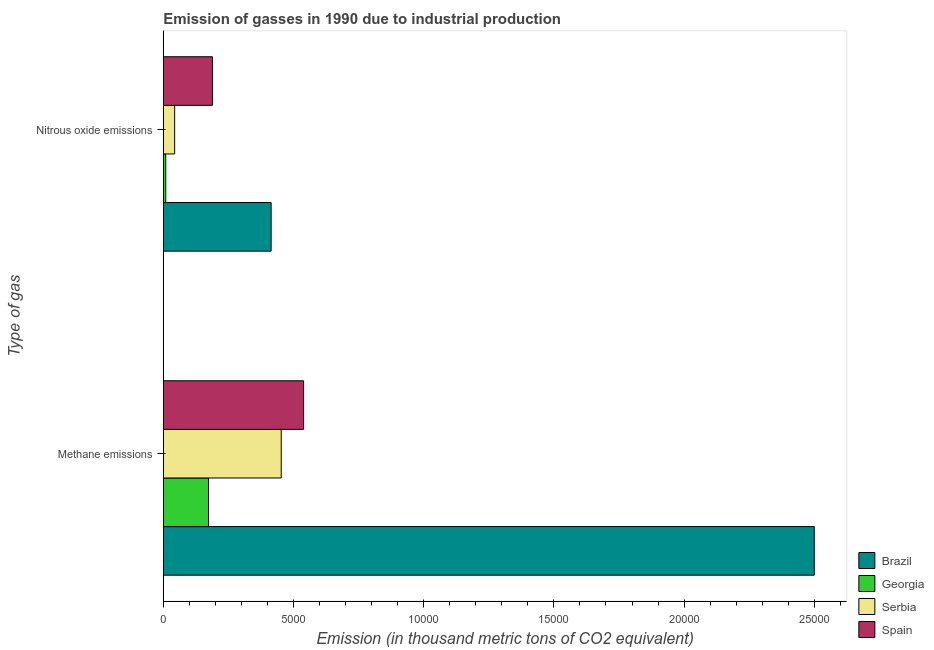How many different coloured bars are there?
Provide a succinct answer. 4. How many groups of bars are there?
Make the answer very short. 2. What is the label of the 2nd group of bars from the top?
Your response must be concise. Methane emissions. What is the amount of methane emissions in Serbia?
Your answer should be very brief. 4529.1. Across all countries, what is the maximum amount of methane emissions?
Your response must be concise. 2.50e+04. Across all countries, what is the minimum amount of nitrous oxide emissions?
Your answer should be compact. 94.9. In which country was the amount of nitrous oxide emissions maximum?
Ensure brevity in your answer.  Brazil. In which country was the amount of methane emissions minimum?
Provide a succinct answer. Georgia. What is the total amount of methane emissions in the graph?
Keep it short and to the point. 3.67e+04. What is the difference between the amount of methane emissions in Spain and that in Brazil?
Make the answer very short. -1.96e+04. What is the difference between the amount of nitrous oxide emissions in Georgia and the amount of methane emissions in Serbia?
Your response must be concise. -4434.2. What is the average amount of nitrous oxide emissions per country?
Give a very brief answer. 1639.3. What is the difference between the amount of methane emissions and amount of nitrous oxide emissions in Serbia?
Ensure brevity in your answer.  4092.9. In how many countries, is the amount of nitrous oxide emissions greater than 18000 thousand metric tons?
Your answer should be very brief. 0. What is the ratio of the amount of nitrous oxide emissions in Brazil to that in Serbia?
Offer a very short reply. 9.49. In how many countries, is the amount of nitrous oxide emissions greater than the average amount of nitrous oxide emissions taken over all countries?
Your answer should be compact. 2. What does the 4th bar from the top in Methane emissions represents?
Keep it short and to the point. Brazil. What does the 2nd bar from the bottom in Methane emissions represents?
Make the answer very short. Georgia. How many countries are there in the graph?
Provide a succinct answer. 4. What is the difference between two consecutive major ticks on the X-axis?
Your answer should be very brief. 5000. Where does the legend appear in the graph?
Your answer should be compact. Bottom right. How are the legend labels stacked?
Keep it short and to the point. Vertical. What is the title of the graph?
Make the answer very short. Emission of gasses in 1990 due to industrial production. What is the label or title of the X-axis?
Ensure brevity in your answer.  Emission (in thousand metric tons of CO2 equivalent). What is the label or title of the Y-axis?
Your response must be concise. Type of gas. What is the Emission (in thousand metric tons of CO2 equivalent) of Brazil in Methane emissions?
Your answer should be compact. 2.50e+04. What is the Emission (in thousand metric tons of CO2 equivalent) in Georgia in Methane emissions?
Offer a terse response. 1736.4. What is the Emission (in thousand metric tons of CO2 equivalent) in Serbia in Methane emissions?
Your answer should be very brief. 4529.1. What is the Emission (in thousand metric tons of CO2 equivalent) in Spain in Methane emissions?
Provide a succinct answer. 5387.8. What is the Emission (in thousand metric tons of CO2 equivalent) of Brazil in Nitrous oxide emissions?
Your answer should be compact. 4140.8. What is the Emission (in thousand metric tons of CO2 equivalent) in Georgia in Nitrous oxide emissions?
Your answer should be very brief. 94.9. What is the Emission (in thousand metric tons of CO2 equivalent) of Serbia in Nitrous oxide emissions?
Provide a short and direct response. 436.2. What is the Emission (in thousand metric tons of CO2 equivalent) of Spain in Nitrous oxide emissions?
Provide a succinct answer. 1885.3. Across all Type of gas, what is the maximum Emission (in thousand metric tons of CO2 equivalent) of Brazil?
Ensure brevity in your answer.  2.50e+04. Across all Type of gas, what is the maximum Emission (in thousand metric tons of CO2 equivalent) in Georgia?
Ensure brevity in your answer.  1736.4. Across all Type of gas, what is the maximum Emission (in thousand metric tons of CO2 equivalent) in Serbia?
Provide a short and direct response. 4529.1. Across all Type of gas, what is the maximum Emission (in thousand metric tons of CO2 equivalent) in Spain?
Your answer should be compact. 5387.8. Across all Type of gas, what is the minimum Emission (in thousand metric tons of CO2 equivalent) in Brazil?
Ensure brevity in your answer.  4140.8. Across all Type of gas, what is the minimum Emission (in thousand metric tons of CO2 equivalent) of Georgia?
Ensure brevity in your answer.  94.9. Across all Type of gas, what is the minimum Emission (in thousand metric tons of CO2 equivalent) in Serbia?
Give a very brief answer. 436.2. Across all Type of gas, what is the minimum Emission (in thousand metric tons of CO2 equivalent) in Spain?
Your response must be concise. 1885.3. What is the total Emission (in thousand metric tons of CO2 equivalent) in Brazil in the graph?
Ensure brevity in your answer.  2.91e+04. What is the total Emission (in thousand metric tons of CO2 equivalent) in Georgia in the graph?
Provide a succinct answer. 1831.3. What is the total Emission (in thousand metric tons of CO2 equivalent) of Serbia in the graph?
Keep it short and to the point. 4965.3. What is the total Emission (in thousand metric tons of CO2 equivalent) in Spain in the graph?
Provide a short and direct response. 7273.1. What is the difference between the Emission (in thousand metric tons of CO2 equivalent) of Brazil in Methane emissions and that in Nitrous oxide emissions?
Keep it short and to the point. 2.09e+04. What is the difference between the Emission (in thousand metric tons of CO2 equivalent) of Georgia in Methane emissions and that in Nitrous oxide emissions?
Provide a short and direct response. 1641.5. What is the difference between the Emission (in thousand metric tons of CO2 equivalent) in Serbia in Methane emissions and that in Nitrous oxide emissions?
Provide a short and direct response. 4092.9. What is the difference between the Emission (in thousand metric tons of CO2 equivalent) in Spain in Methane emissions and that in Nitrous oxide emissions?
Keep it short and to the point. 3502.5. What is the difference between the Emission (in thousand metric tons of CO2 equivalent) in Brazil in Methane emissions and the Emission (in thousand metric tons of CO2 equivalent) in Georgia in Nitrous oxide emissions?
Your response must be concise. 2.49e+04. What is the difference between the Emission (in thousand metric tons of CO2 equivalent) of Brazil in Methane emissions and the Emission (in thousand metric tons of CO2 equivalent) of Serbia in Nitrous oxide emissions?
Offer a very short reply. 2.46e+04. What is the difference between the Emission (in thousand metric tons of CO2 equivalent) of Brazil in Methane emissions and the Emission (in thousand metric tons of CO2 equivalent) of Spain in Nitrous oxide emissions?
Provide a short and direct response. 2.31e+04. What is the difference between the Emission (in thousand metric tons of CO2 equivalent) of Georgia in Methane emissions and the Emission (in thousand metric tons of CO2 equivalent) of Serbia in Nitrous oxide emissions?
Offer a terse response. 1300.2. What is the difference between the Emission (in thousand metric tons of CO2 equivalent) in Georgia in Methane emissions and the Emission (in thousand metric tons of CO2 equivalent) in Spain in Nitrous oxide emissions?
Offer a terse response. -148.9. What is the difference between the Emission (in thousand metric tons of CO2 equivalent) in Serbia in Methane emissions and the Emission (in thousand metric tons of CO2 equivalent) in Spain in Nitrous oxide emissions?
Offer a very short reply. 2643.8. What is the average Emission (in thousand metric tons of CO2 equivalent) of Brazil per Type of gas?
Your response must be concise. 1.46e+04. What is the average Emission (in thousand metric tons of CO2 equivalent) in Georgia per Type of gas?
Offer a very short reply. 915.65. What is the average Emission (in thousand metric tons of CO2 equivalent) of Serbia per Type of gas?
Your answer should be compact. 2482.65. What is the average Emission (in thousand metric tons of CO2 equivalent) in Spain per Type of gas?
Provide a succinct answer. 3636.55. What is the difference between the Emission (in thousand metric tons of CO2 equivalent) of Brazil and Emission (in thousand metric tons of CO2 equivalent) of Georgia in Methane emissions?
Provide a succinct answer. 2.33e+04. What is the difference between the Emission (in thousand metric tons of CO2 equivalent) of Brazil and Emission (in thousand metric tons of CO2 equivalent) of Serbia in Methane emissions?
Keep it short and to the point. 2.05e+04. What is the difference between the Emission (in thousand metric tons of CO2 equivalent) in Brazil and Emission (in thousand metric tons of CO2 equivalent) in Spain in Methane emissions?
Offer a terse response. 1.96e+04. What is the difference between the Emission (in thousand metric tons of CO2 equivalent) of Georgia and Emission (in thousand metric tons of CO2 equivalent) of Serbia in Methane emissions?
Offer a terse response. -2792.7. What is the difference between the Emission (in thousand metric tons of CO2 equivalent) of Georgia and Emission (in thousand metric tons of CO2 equivalent) of Spain in Methane emissions?
Your response must be concise. -3651.4. What is the difference between the Emission (in thousand metric tons of CO2 equivalent) in Serbia and Emission (in thousand metric tons of CO2 equivalent) in Spain in Methane emissions?
Provide a succinct answer. -858.7. What is the difference between the Emission (in thousand metric tons of CO2 equivalent) in Brazil and Emission (in thousand metric tons of CO2 equivalent) in Georgia in Nitrous oxide emissions?
Your answer should be compact. 4045.9. What is the difference between the Emission (in thousand metric tons of CO2 equivalent) of Brazil and Emission (in thousand metric tons of CO2 equivalent) of Serbia in Nitrous oxide emissions?
Make the answer very short. 3704.6. What is the difference between the Emission (in thousand metric tons of CO2 equivalent) in Brazil and Emission (in thousand metric tons of CO2 equivalent) in Spain in Nitrous oxide emissions?
Offer a terse response. 2255.5. What is the difference between the Emission (in thousand metric tons of CO2 equivalent) in Georgia and Emission (in thousand metric tons of CO2 equivalent) in Serbia in Nitrous oxide emissions?
Ensure brevity in your answer.  -341.3. What is the difference between the Emission (in thousand metric tons of CO2 equivalent) of Georgia and Emission (in thousand metric tons of CO2 equivalent) of Spain in Nitrous oxide emissions?
Give a very brief answer. -1790.4. What is the difference between the Emission (in thousand metric tons of CO2 equivalent) in Serbia and Emission (in thousand metric tons of CO2 equivalent) in Spain in Nitrous oxide emissions?
Ensure brevity in your answer.  -1449.1. What is the ratio of the Emission (in thousand metric tons of CO2 equivalent) of Brazil in Methane emissions to that in Nitrous oxide emissions?
Give a very brief answer. 6.04. What is the ratio of the Emission (in thousand metric tons of CO2 equivalent) of Georgia in Methane emissions to that in Nitrous oxide emissions?
Offer a very short reply. 18.3. What is the ratio of the Emission (in thousand metric tons of CO2 equivalent) of Serbia in Methane emissions to that in Nitrous oxide emissions?
Ensure brevity in your answer.  10.38. What is the ratio of the Emission (in thousand metric tons of CO2 equivalent) in Spain in Methane emissions to that in Nitrous oxide emissions?
Your response must be concise. 2.86. What is the difference between the highest and the second highest Emission (in thousand metric tons of CO2 equivalent) of Brazil?
Ensure brevity in your answer.  2.09e+04. What is the difference between the highest and the second highest Emission (in thousand metric tons of CO2 equivalent) in Georgia?
Your answer should be compact. 1641.5. What is the difference between the highest and the second highest Emission (in thousand metric tons of CO2 equivalent) of Serbia?
Offer a very short reply. 4092.9. What is the difference between the highest and the second highest Emission (in thousand metric tons of CO2 equivalent) in Spain?
Your answer should be very brief. 3502.5. What is the difference between the highest and the lowest Emission (in thousand metric tons of CO2 equivalent) of Brazil?
Your answer should be compact. 2.09e+04. What is the difference between the highest and the lowest Emission (in thousand metric tons of CO2 equivalent) in Georgia?
Your response must be concise. 1641.5. What is the difference between the highest and the lowest Emission (in thousand metric tons of CO2 equivalent) of Serbia?
Offer a very short reply. 4092.9. What is the difference between the highest and the lowest Emission (in thousand metric tons of CO2 equivalent) in Spain?
Offer a terse response. 3502.5. 